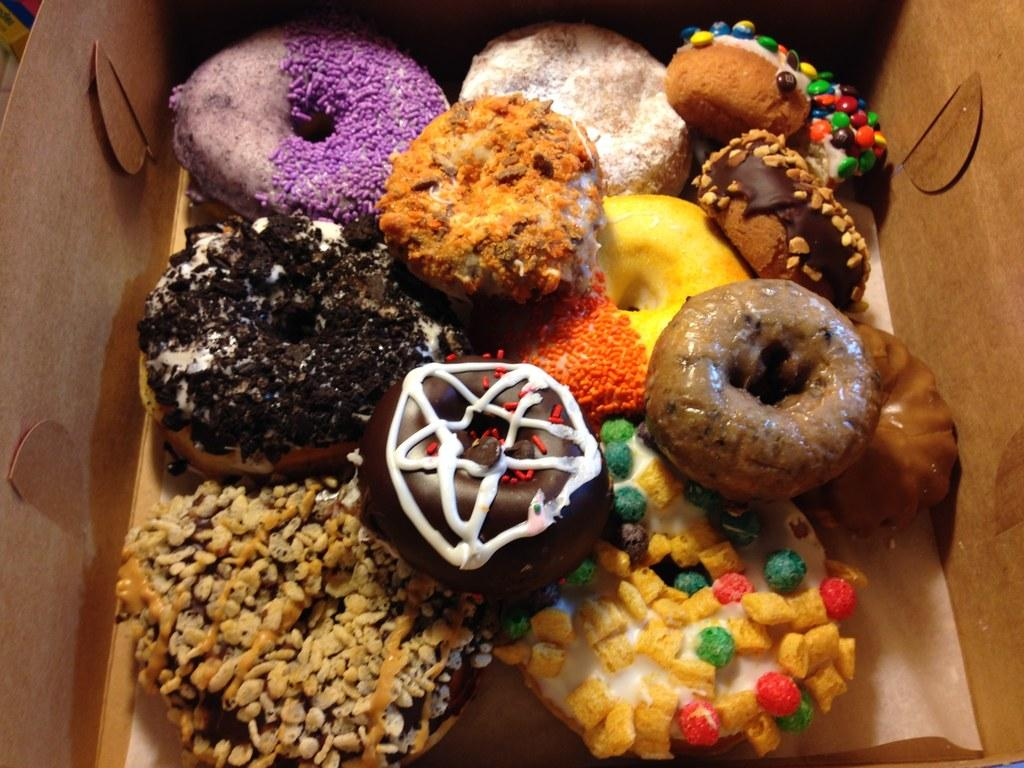What object is present in the image that is typically used for storage or transportation? There is a cardboard box in the image. What is inside the cardboard box? The box contains doughnuts. How diverse are the doughnuts in the box? The doughnuts have different types. What visual characteristic distinguishes the doughnuts from one another? The doughnuts have different colors. What degree of difficulty is required to wear the crown on the doughnut in the image? There is no crown present on any of the doughnuts in the image. 